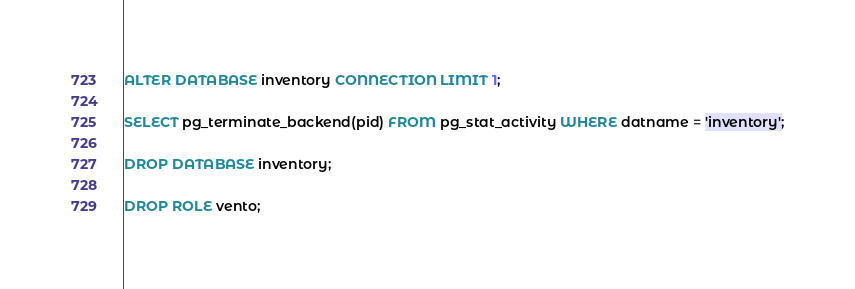Convert code to text. <code><loc_0><loc_0><loc_500><loc_500><_SQL_>
ALTER DATABASE inventory CONNECTION LIMIT 1;

SELECT pg_terminate_backend(pid) FROM pg_stat_activity WHERE datname = 'inventory';

DROP DATABASE inventory;

DROP ROLE vento;</code> 